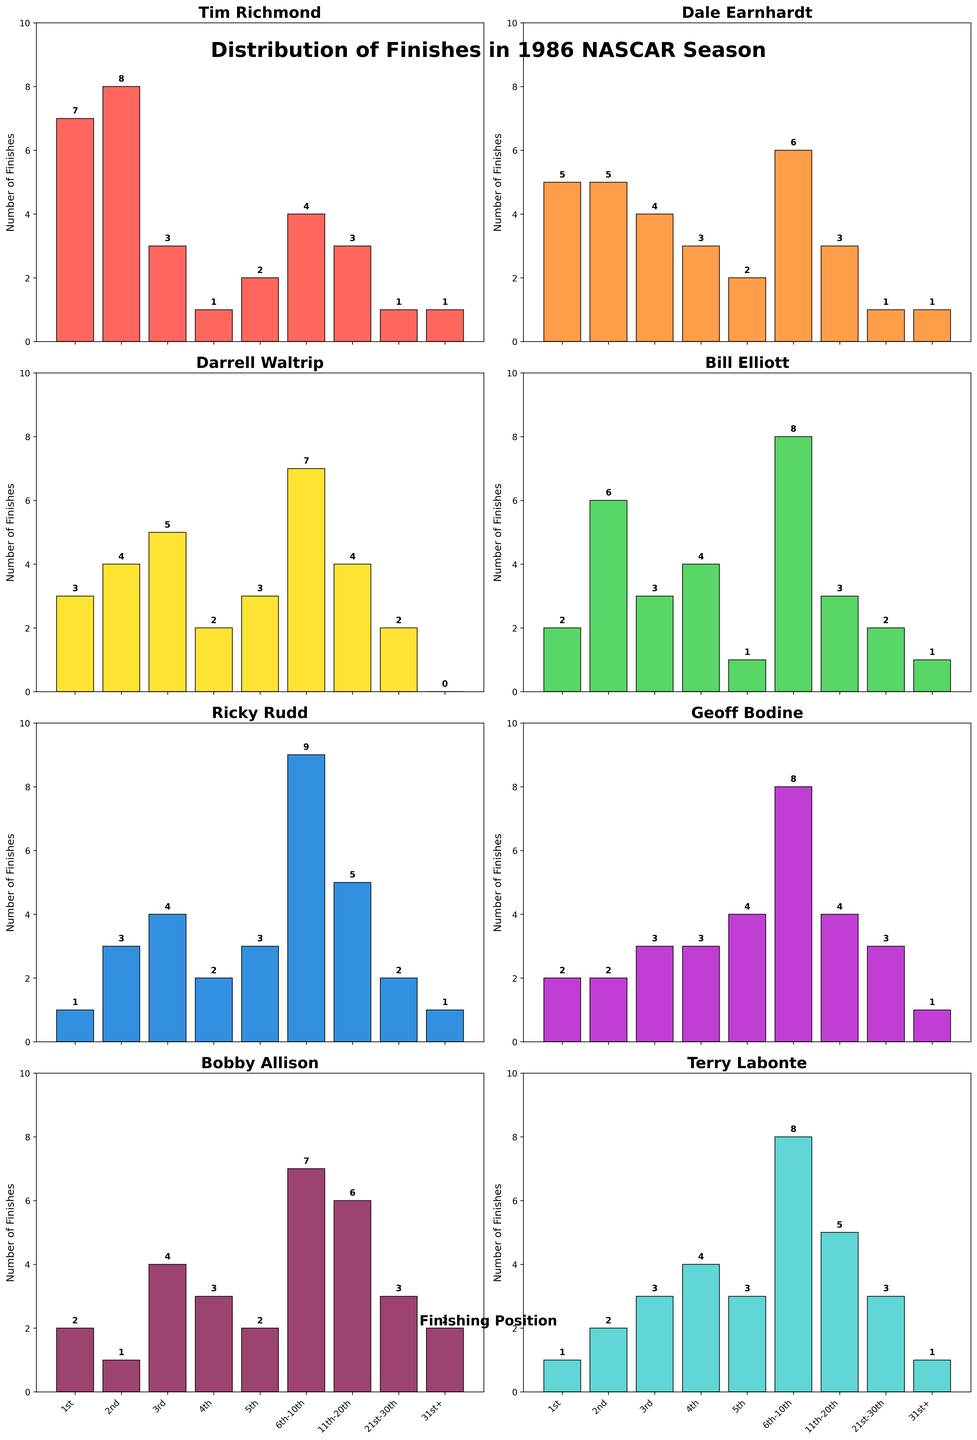Which driver had the most 1st place finishes in 1986? Looking at the height of the bars for the "1st" position, we can see that Tim Richmond's bar is the tallest. By counting, it's clear that he had 7 first-place finishes.
Answer: Tim Richmond How many more 1st place finishes did Tim Richmond have than Dale Earnhardt? Tim Richmond had 7 wins (1st place finishes), and Dale Earnhardt had 5. The difference is calculated as 7 - 5.
Answer: 2 Comparing the 6th-10th place finishes, who had more, Bill Elliott or Geoff Bodine? The height of the bars for "6th-10th" shows that Bill Elliott had 8 finishes while Geoff Bodine had 8 as well. Since they are the same height and the same number, neither had more than the other.
Answer: Equal Which driver had the most consistent top 5 finishes, and how do you know? By looking at the combined heights of the bars for 1st, 2nd, 3rd, 4th, and 5th positions, Tim Richmond has the highest combined height. His finishes in the top 5 are 7 + 8 + 3 + 1 + 2 = 21.
Answer: Tim Richmond Which driver had the least number of finishes in the 31st+ position? Examining the height of the bars for "31st+", Tim Richmond, Dale Earnhardt, Darrell Waltrip, and Ricky Rudd each had no finishes (bar height is zero). So, multiple drivers had the least number, which is zero.
Answer: Tim Richmond, Dale Earnhardt, Darrell Waltrip, Ricky Rudd Who had more finishes in positions 11th-20th, Bobby Allison or Terry Labonte? Looking at the bar heights for the "11th-20th" position, Bobby Allison's bar is taller with 6 finishes compared to Terry Labonte's 5 finishes.
Answer: Bobby Allison Between Darrell Waltrip and Ricky Rudd, who had more 3rd place finishes? Darrell Waltrip had 5 third-place finishes, and Ricky Rudd had 4. By comparing the bars for "3rd," Darrell Waltrip's bar is taller.
Answer: Darrell Waltrip How many more races did Tim Richmond finish in the top 3 compared to Bill Elliott? Summing the counts for Tim Richmond's 1st, 2nd, and 3rd places gives 7 + 8 + 3 = 18. For Bill Elliott, it is 2 + 6 + 3 = 11. The difference is 18 - 11.
Answer: 7 Which driver had the most finishes between 11th and 20th position? Evaluating the height of bars for "11th-20th," Bobby Allison's bar stands tallest at 6 finishes.
Answer: Bobby Allison Who had more finishes in the 21st-30th position, Ricky Rudd or Bobby Allison? Inspecting the height of the bars for "21st-30th," both Ricky Rudd and Bobby Allison had 3 finishes each; thus, the bars are of equal height.
Answer: Equal 